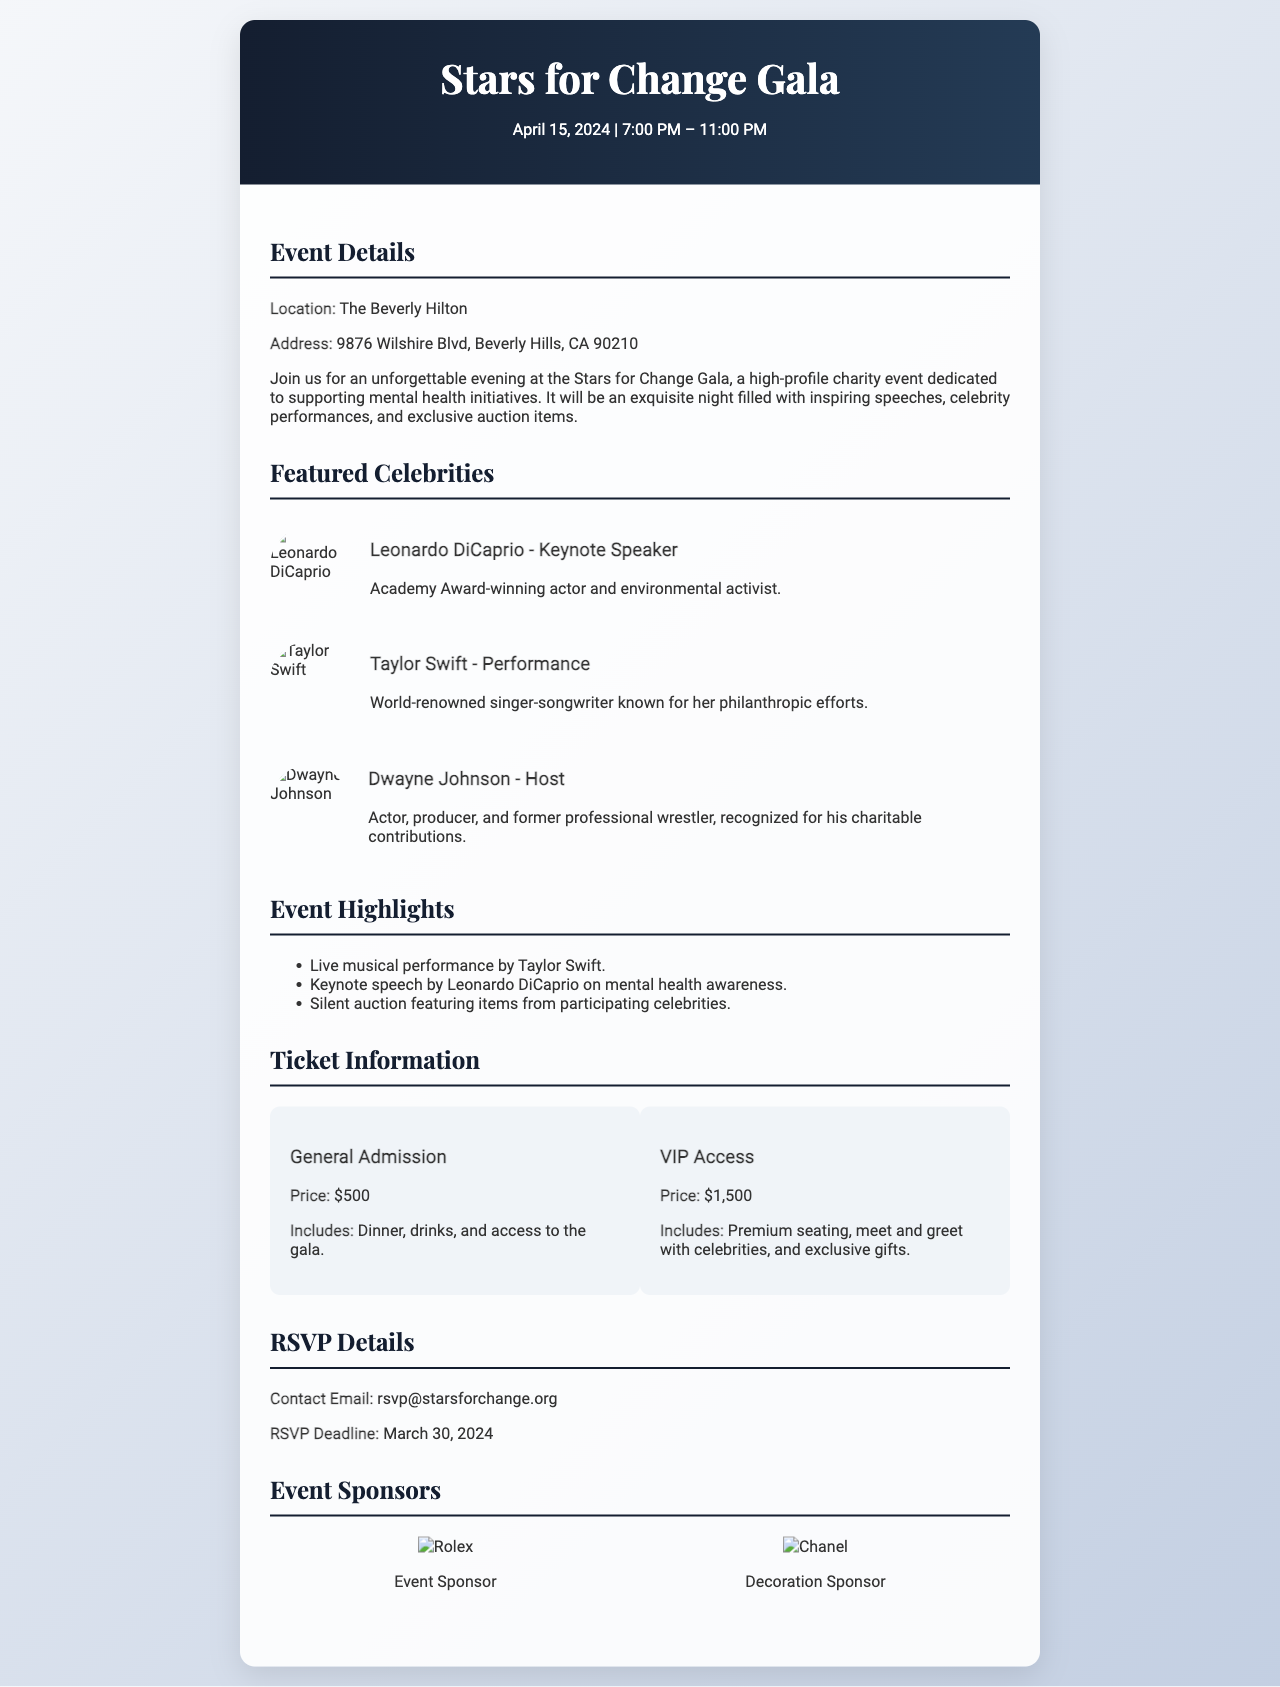What is the date of the event? The date of the Stars for Change Gala is mentioned at the beginning of the document.
Answer: April 15, 2024 Where is the gala being held? The location of the event is specified in the event details section.
Answer: The Beverly Hilton Who is the keynote speaker? The featured celebrities section lists Leonardo DiCaprio as the keynote speaker.
Answer: Leonardo DiCaprio What is the price of VIP access tickets? The ticket information section provides the price for VIP access.
Answer: $1,500 What is the RSVP deadline? The RSVP details section clearly states the RSVP deadline.
Answer: March 30, 2024 Which celebrity is hosting the gala? The featured celebrities section indicates Dwayne Johnson as the host.
Answer: Dwayne Johnson What type of event is the Stars for Change Gala? The event details describe the purpose of the gala.
Answer: Charity event What is included in General Admission? The ticket information lists what is included in General Admission.
Answer: Dinner, drinks, and access to the gala 